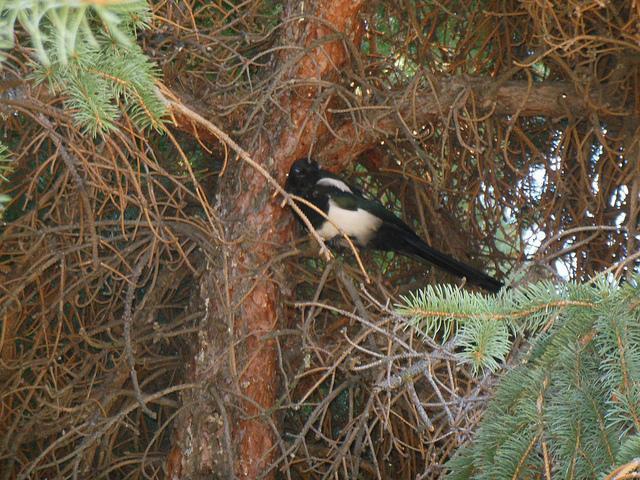How many people are sitting in the 4th row in the image?
Give a very brief answer. 0. 